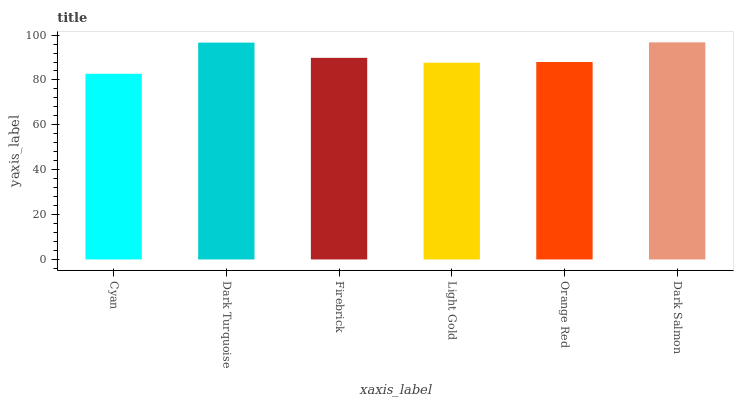Is Dark Turquoise the minimum?
Answer yes or no. No. Is Dark Turquoise the maximum?
Answer yes or no. No. Is Dark Turquoise greater than Cyan?
Answer yes or no. Yes. Is Cyan less than Dark Turquoise?
Answer yes or no. Yes. Is Cyan greater than Dark Turquoise?
Answer yes or no. No. Is Dark Turquoise less than Cyan?
Answer yes or no. No. Is Firebrick the high median?
Answer yes or no. Yes. Is Orange Red the low median?
Answer yes or no. Yes. Is Light Gold the high median?
Answer yes or no. No. Is Cyan the low median?
Answer yes or no. No. 